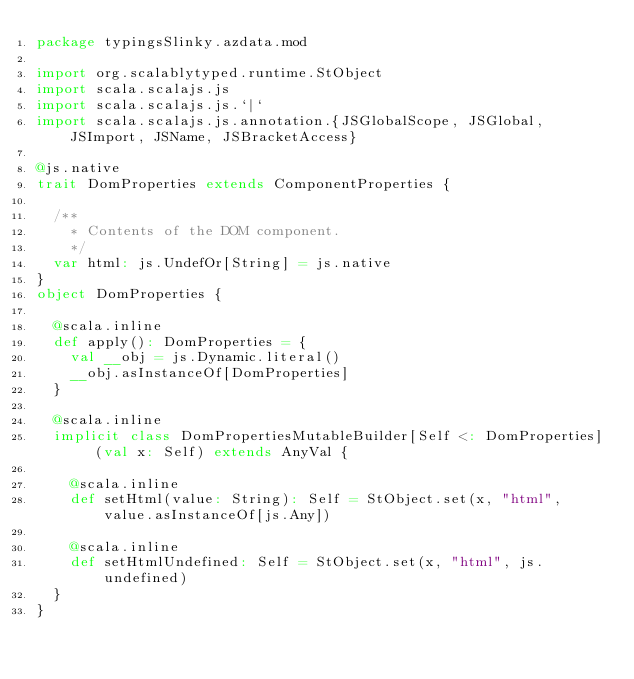<code> <loc_0><loc_0><loc_500><loc_500><_Scala_>package typingsSlinky.azdata.mod

import org.scalablytyped.runtime.StObject
import scala.scalajs.js
import scala.scalajs.js.`|`
import scala.scalajs.js.annotation.{JSGlobalScope, JSGlobal, JSImport, JSName, JSBracketAccess}

@js.native
trait DomProperties extends ComponentProperties {
  
  /**
    * Contents of the DOM component.
    */
  var html: js.UndefOr[String] = js.native
}
object DomProperties {
  
  @scala.inline
  def apply(): DomProperties = {
    val __obj = js.Dynamic.literal()
    __obj.asInstanceOf[DomProperties]
  }
  
  @scala.inline
  implicit class DomPropertiesMutableBuilder[Self <: DomProperties] (val x: Self) extends AnyVal {
    
    @scala.inline
    def setHtml(value: String): Self = StObject.set(x, "html", value.asInstanceOf[js.Any])
    
    @scala.inline
    def setHtmlUndefined: Self = StObject.set(x, "html", js.undefined)
  }
}
</code> 